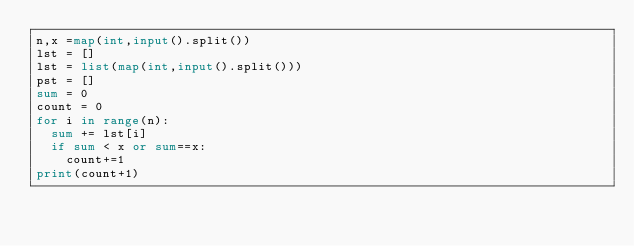<code> <loc_0><loc_0><loc_500><loc_500><_Python_>n,x =map(int,input().split())
lst = []
lst = list(map(int,input().split()))
pst = []
sum = 0
count = 0
for i in range(n):
  sum += lst[i]
  if sum < x or sum==x:
    count+=1
print(count+1)
  </code> 